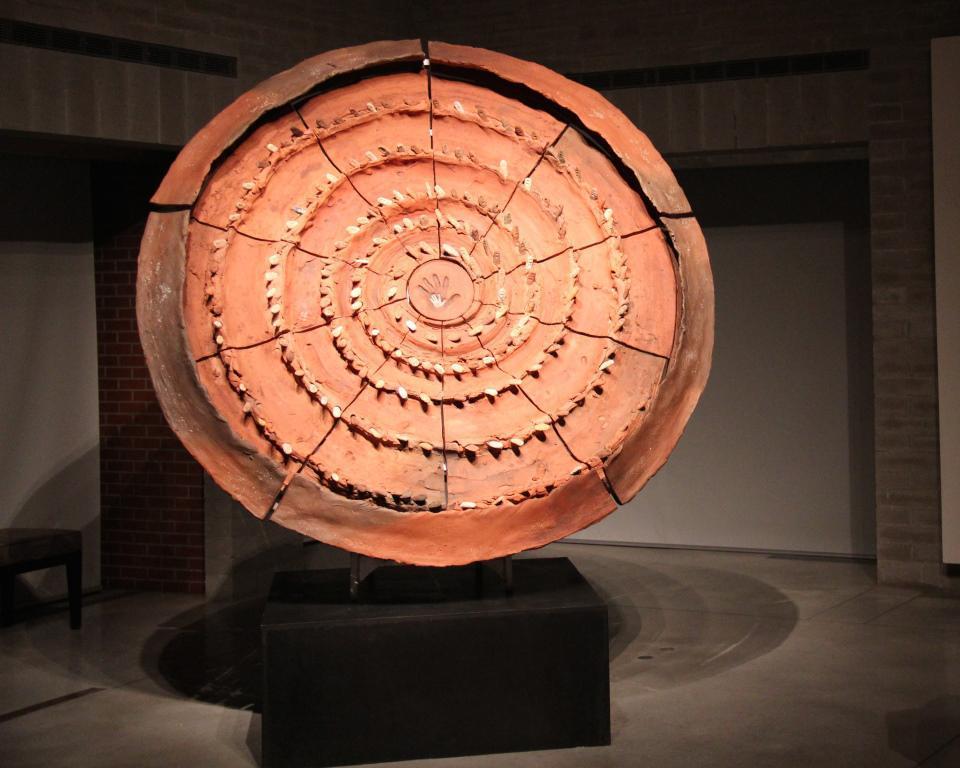Could you give a brief overview of what you see in this image? In this image we can see a artifact placed on the ground. In the background we can see a chair. 